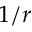<formula> <loc_0><loc_0><loc_500><loc_500>1 / r</formula> 